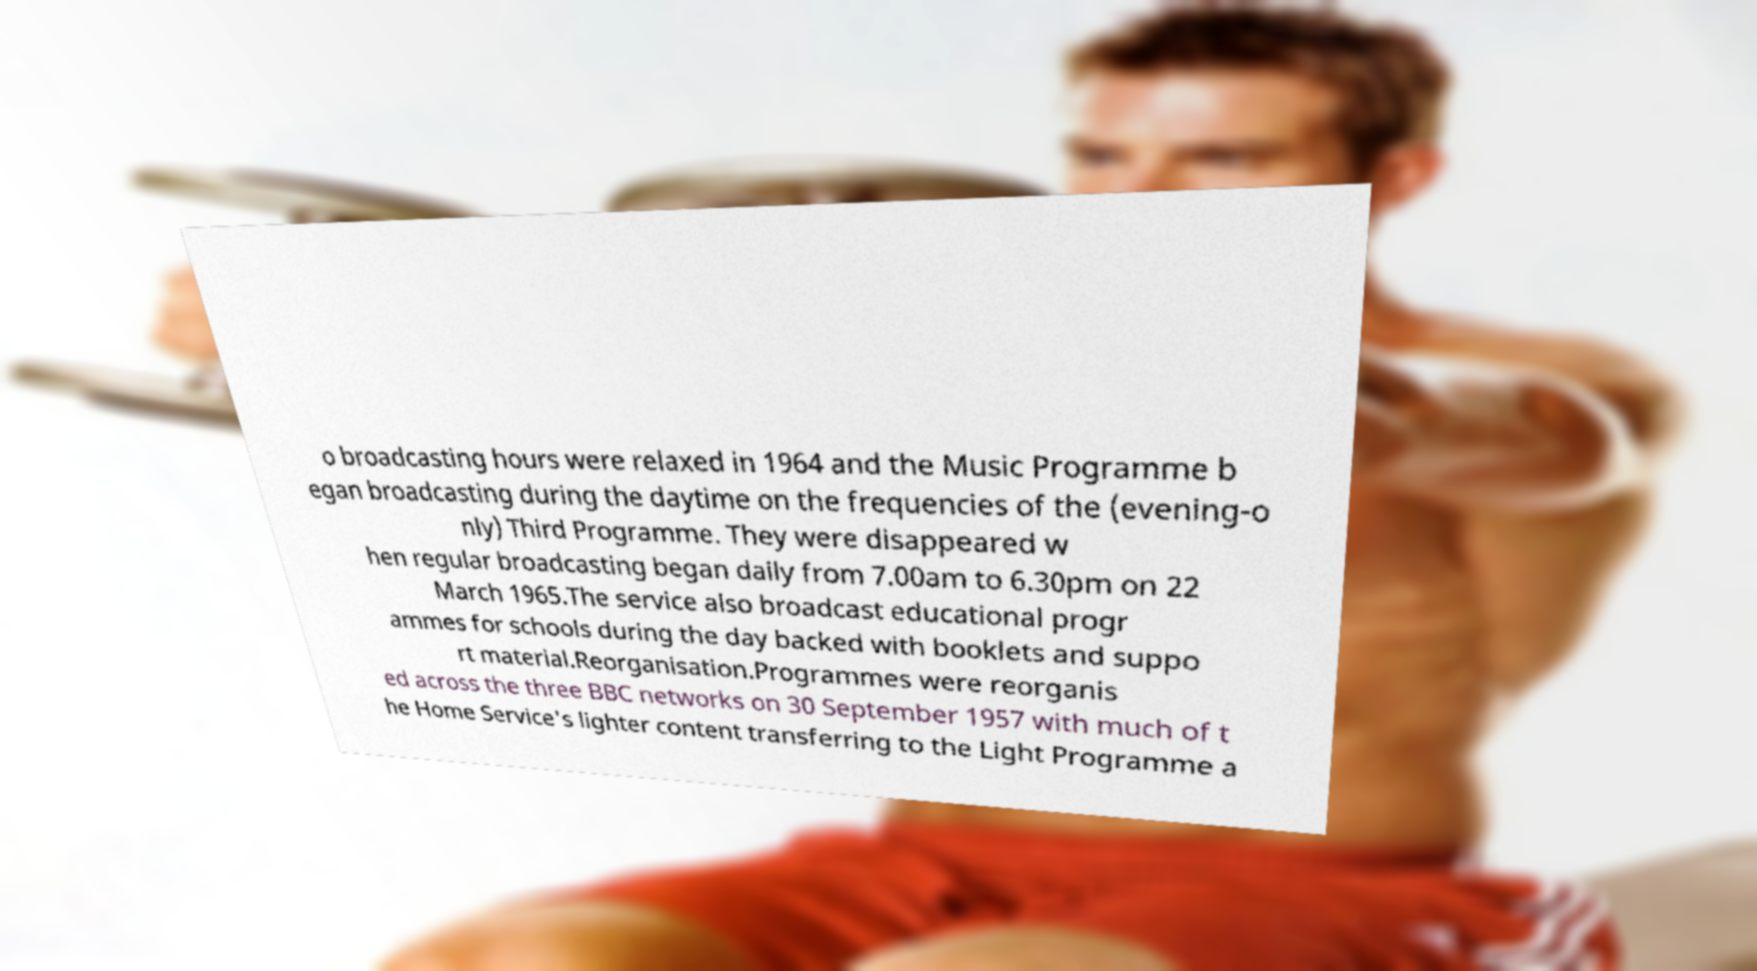Could you extract and type out the text from this image? o broadcasting hours were relaxed in 1964 and the Music Programme b egan broadcasting during the daytime on the frequencies of the (evening-o nly) Third Programme. They were disappeared w hen regular broadcasting began daily from 7.00am to 6.30pm on 22 March 1965.The service also broadcast educational progr ammes for schools during the day backed with booklets and suppo rt material.Reorganisation.Programmes were reorganis ed across the three BBC networks on 30 September 1957 with much of t he Home Service's lighter content transferring to the Light Programme a 